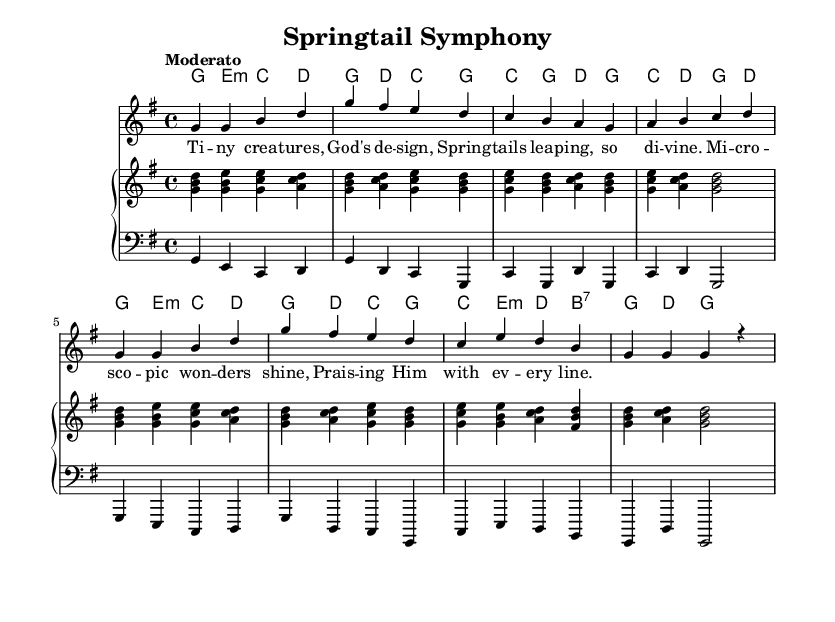What is the key signature of this music? The key signature is G major, which has one sharp (F#). This can be deduced from the global section that specifies \key g \major.
Answer: G major What is the time signature of this piece? The time signature is 4/4, as stated in the global section with \time 4/4. This means there are four beats in a measure and the quarter note receives one beat.
Answer: 4/4 What is the tempo marking for this piece? The tempo marking indicates "Moderato," which suggests a moderate pace. This can be found in the global section of the music coding.
Answer: Moderato How many measures are there in the melody section? The melody has a total of 8 measures. By counting the measures in the melody section, we can see there are 8 groups of notes separated by vertical lines.
Answer: 8 What is the lyrical theme of this song? The lyrics celebrate the wonders of microscopic life, specifically springtails, and praise their divine creation. This is evident from the lyrics section which directly references "Tiny creatures, God's design."
Answer: Praise Which instruments are used in this piece? The piece features two primary instruments: "acoustic grand" for the upper staff and "church organ" for the lower staff, as noted in the respective instruments indicated in each staff section.
Answer: Acoustic grand, church organ What is the harmonic progression of the first measure? The harmonic progression in the first measure is G major, E minor, C major, and D major, as detailed in the harmonies section where the chords are specified for that measure.
Answer: G, E minor, C, D 